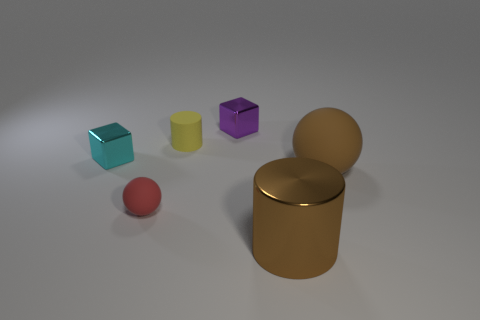Add 1 large shiny things. How many objects exist? 7 Subtract all spheres. How many objects are left? 4 Add 6 matte spheres. How many matte spheres are left? 8 Add 4 small cyan metal objects. How many small cyan metal objects exist? 5 Subtract 1 cyan blocks. How many objects are left? 5 Subtract all purple shiny cubes. Subtract all tiny shiny objects. How many objects are left? 3 